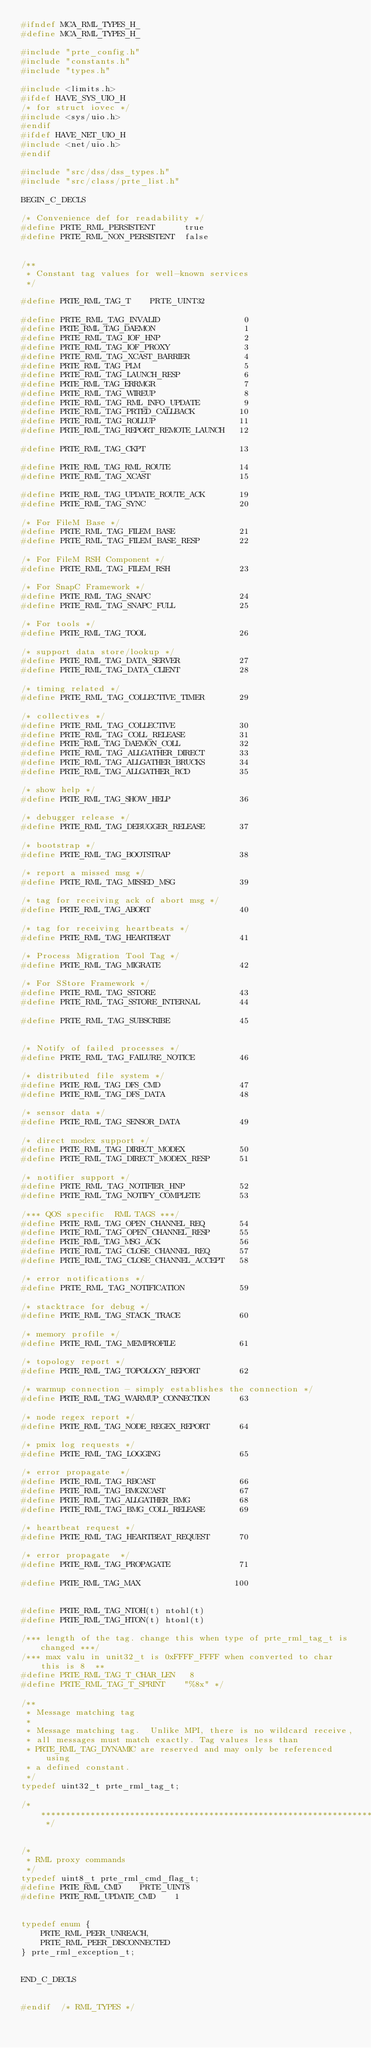<code> <loc_0><loc_0><loc_500><loc_500><_C_>#ifndef MCA_RML_TYPES_H_
#define MCA_RML_TYPES_H_

#include "prte_config.h"
#include "constants.h"
#include "types.h"

#include <limits.h>
#ifdef HAVE_SYS_UIO_H
/* for struct iovec */
#include <sys/uio.h>
#endif
#ifdef HAVE_NET_UIO_H
#include <net/uio.h>
#endif

#include "src/dss/dss_types.h"
#include "src/class/prte_list.h"

BEGIN_C_DECLS

/* Convenience def for readability */
#define PRTE_RML_PERSISTENT      true
#define PRTE_RML_NON_PERSISTENT  false


/**
 * Constant tag values for well-known services
 */

#define PRTE_RML_TAG_T    PRTE_UINT32

#define PRTE_RML_TAG_INVALID                 0
#define PRTE_RML_TAG_DAEMON                  1
#define PRTE_RML_TAG_IOF_HNP                 2
#define PRTE_RML_TAG_IOF_PROXY               3
#define PRTE_RML_TAG_XCAST_BARRIER           4
#define PRTE_RML_TAG_PLM                     5
#define PRTE_RML_TAG_LAUNCH_RESP             6
#define PRTE_RML_TAG_ERRMGR                  7
#define PRTE_RML_TAG_WIREUP                  8
#define PRTE_RML_TAG_RML_INFO_UPDATE         9
#define PRTE_RML_TAG_PRTED_CALLBACK         10
#define PRTE_RML_TAG_ROLLUP                 11
#define PRTE_RML_TAG_REPORT_REMOTE_LAUNCH   12

#define PRTE_RML_TAG_CKPT                   13

#define PRTE_RML_TAG_RML_ROUTE              14
#define PRTE_RML_TAG_XCAST                  15

#define PRTE_RML_TAG_UPDATE_ROUTE_ACK       19
#define PRTE_RML_TAG_SYNC                   20

/* For FileM Base */
#define PRTE_RML_TAG_FILEM_BASE             21
#define PRTE_RML_TAG_FILEM_BASE_RESP        22

/* For FileM RSH Component */
#define PRTE_RML_TAG_FILEM_RSH              23

/* For SnapC Framework */
#define PRTE_RML_TAG_SNAPC                  24
#define PRTE_RML_TAG_SNAPC_FULL             25

/* For tools */
#define PRTE_RML_TAG_TOOL                   26

/* support data store/lookup */
#define PRTE_RML_TAG_DATA_SERVER            27
#define PRTE_RML_TAG_DATA_CLIENT            28

/* timing related */
#define PRTE_RML_TAG_COLLECTIVE_TIMER       29

/* collectives */
#define PRTE_RML_TAG_COLLECTIVE             30
#define PRTE_RML_TAG_COLL_RELEASE           31
#define PRTE_RML_TAG_DAEMON_COLL            32
#define PRTE_RML_TAG_ALLGATHER_DIRECT       33
#define PRTE_RML_TAG_ALLGATHER_BRUCKS       34
#define PRTE_RML_TAG_ALLGATHER_RCD          35

/* show help */
#define PRTE_RML_TAG_SHOW_HELP              36

/* debugger release */
#define PRTE_RML_TAG_DEBUGGER_RELEASE       37

/* bootstrap */
#define PRTE_RML_TAG_BOOTSTRAP              38

/* report a missed msg */
#define PRTE_RML_TAG_MISSED_MSG             39

/* tag for receiving ack of abort msg */
#define PRTE_RML_TAG_ABORT                  40

/* tag for receiving heartbeats */
#define PRTE_RML_TAG_HEARTBEAT              41

/* Process Migration Tool Tag */
#define PRTE_RML_TAG_MIGRATE                42

/* For SStore Framework */
#define PRTE_RML_TAG_SSTORE                 43
#define PRTE_RML_TAG_SSTORE_INTERNAL        44

#define PRTE_RML_TAG_SUBSCRIBE              45


/* Notify of failed processes */
#define PRTE_RML_TAG_FAILURE_NOTICE         46

/* distributed file system */
#define PRTE_RML_TAG_DFS_CMD                47
#define PRTE_RML_TAG_DFS_DATA               48

/* sensor data */
#define PRTE_RML_TAG_SENSOR_DATA            49

/* direct modex support */
#define PRTE_RML_TAG_DIRECT_MODEX           50
#define PRTE_RML_TAG_DIRECT_MODEX_RESP      51

/* notifier support */
#define PRTE_RML_TAG_NOTIFIER_HNP           52
#define PRTE_RML_TAG_NOTIFY_COMPLETE        53

/*** QOS specific  RML TAGS ***/
#define PRTE_RML_TAG_OPEN_CHANNEL_REQ       54
#define PRTE_RML_TAG_OPEN_CHANNEL_RESP      55
#define PRTE_RML_TAG_MSG_ACK                56
#define PRTE_RML_TAG_CLOSE_CHANNEL_REQ      57
#define PRTE_RML_TAG_CLOSE_CHANNEL_ACCEPT   58

/* error notifications */
#define PRTE_RML_TAG_NOTIFICATION           59

/* stacktrace for debug */
#define PRTE_RML_TAG_STACK_TRACE            60

/* memory profile */
#define PRTE_RML_TAG_MEMPROFILE             61

/* topology report */
#define PRTE_RML_TAG_TOPOLOGY_REPORT        62

/* warmup connection - simply establishes the connection */
#define PRTE_RML_TAG_WARMUP_CONNECTION      63

/* node regex report */
#define PRTE_RML_TAG_NODE_REGEX_REPORT      64

/* pmix log requests */
#define PRTE_RML_TAG_LOGGING                65

/* error propagate  */
#define PRTE_RML_TAG_RBCAST                 66
#define PRTE_RML_TAG_BMGXCAST               67
#define PRTE_RML_TAG_ALLGATHER_BMG          68
#define PRTE_RML_TAG_BMG_COLL_RELEASE       69

/* heartbeat request */
#define PRTE_RML_TAG_HEARTBEAT_REQUEST      70

/* error propagate  */
#define PRTE_RML_TAG_PROPAGATE              71

#define PRTE_RML_TAG_MAX                   100


#define PRTE_RML_TAG_NTOH(t) ntohl(t)
#define PRTE_RML_TAG_HTON(t) htonl(t)

/*** length of the tag. change this when type of prte_rml_tag_t is changed ***/
/*** max valu in unit32_t is 0xFFFF_FFFF when converted to char this is 8  **
#define PRTE_RML_TAG_T_CHAR_LEN   8
#define PRTE_RML_TAG_T_SPRINT    "%8x" */

/**
 * Message matching tag
 *
 * Message matching tag.  Unlike MPI, there is no wildcard receive,
 * all messages must match exactly. Tag values less than
 * PRTE_RML_TAG_DYNAMIC are reserved and may only be referenced using
 * a defined constant.
 */
typedef uint32_t prte_rml_tag_t;

/* ******************************************************************** */


/*
 * RML proxy commands
 */
typedef uint8_t prte_rml_cmd_flag_t;
#define PRTE_RML_CMD    PRTE_UINT8
#define PRTE_RML_UPDATE_CMD    1


typedef enum {
    PRTE_RML_PEER_UNREACH,
    PRTE_RML_PEER_DISCONNECTED
} prte_rml_exception_t;


END_C_DECLS


#endif  /* RML_TYPES */
</code> 